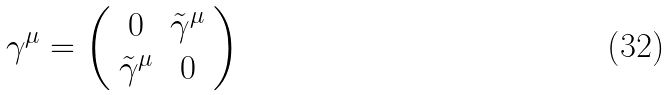Convert formula to latex. <formula><loc_0><loc_0><loc_500><loc_500>\gamma ^ { \mu } = \left ( \begin{array} { c c } { 0 } & { { \tilde { \gamma } ^ { \mu } } } \\ { { \tilde { \gamma } ^ { \mu } } } & { 0 } \end{array} \right )</formula> 